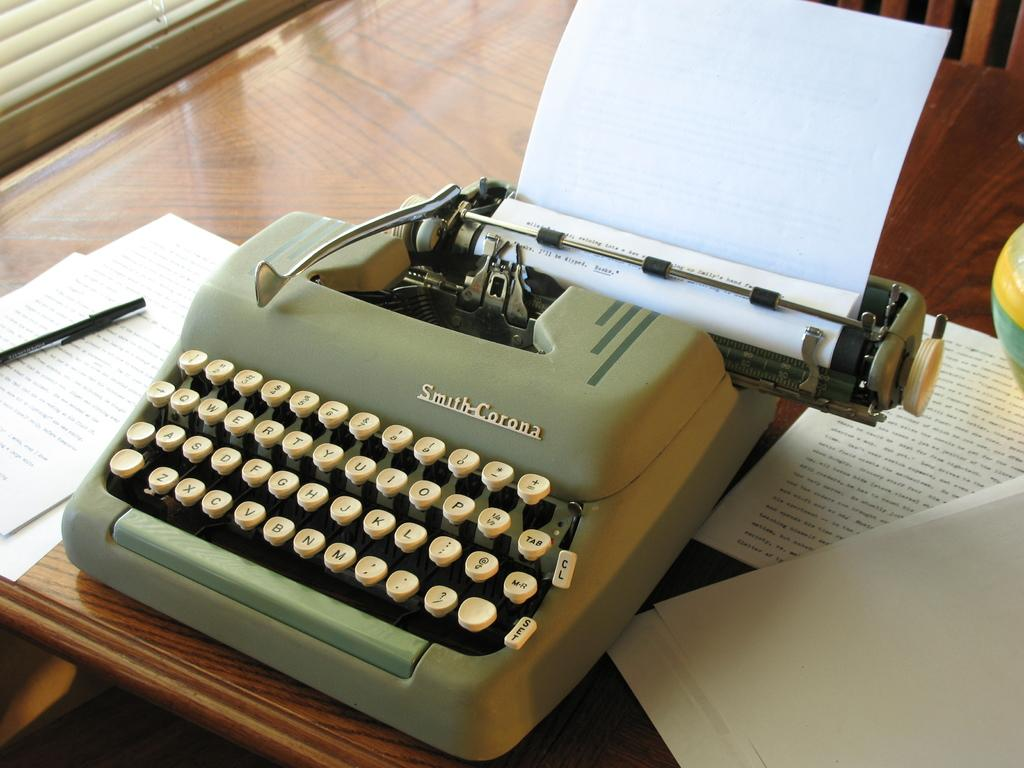<image>
Provide a brief description of the given image. The green typewriter with white keys is a Smith-Corona. 